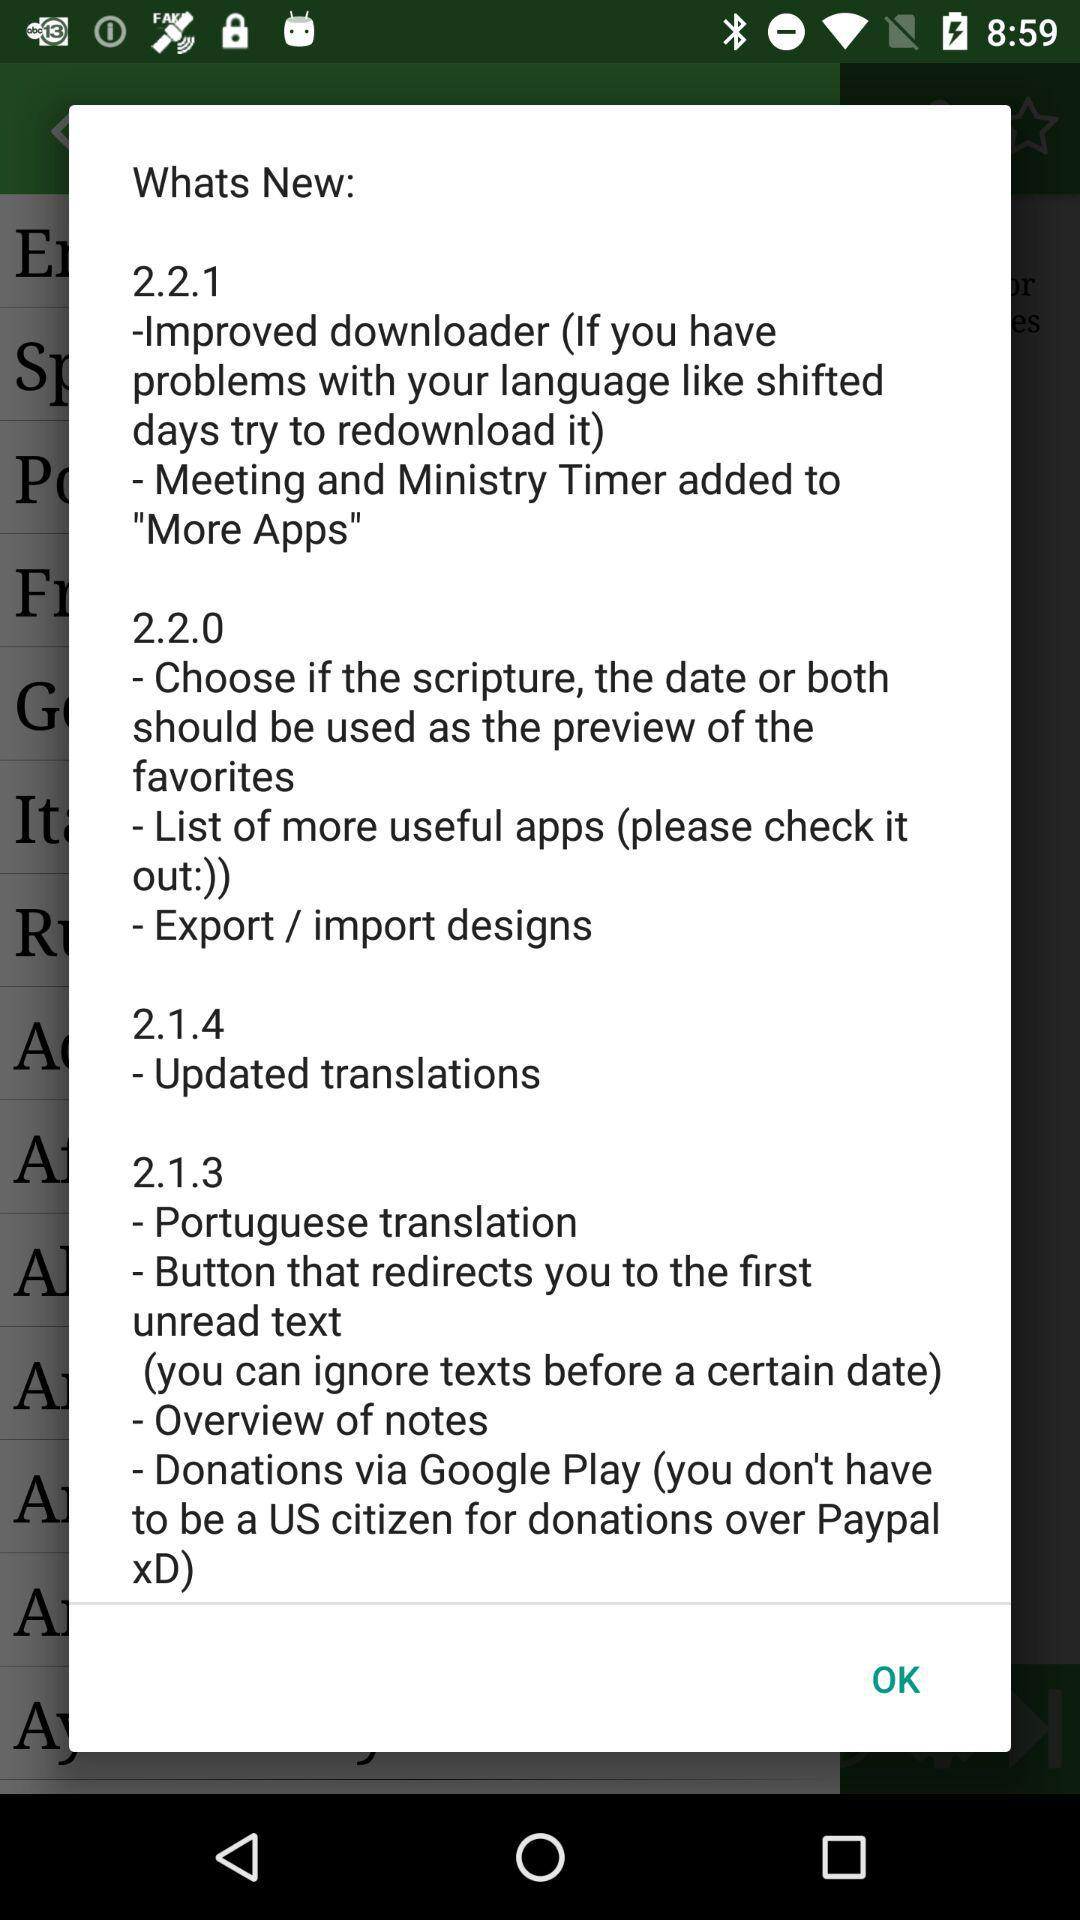How many updates does version 2.1.2?
When the provided information is insufficient, respond with <no answer>. <no answer> 